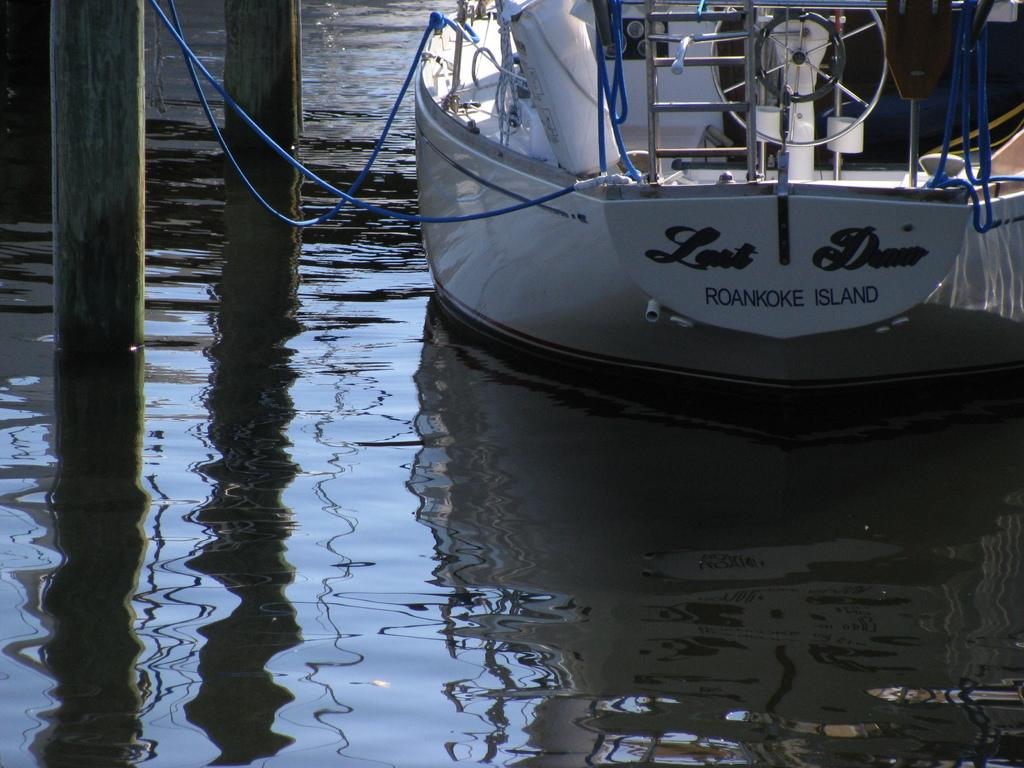What is the main subject of the image? The main subject of the image is a boat. Where is the boat located? The boat is on the water. What can be seen to the left of the boat? There are poles to the left of the boat. What color are the ropes in the image? The ropes in the image are blue. What is another feature visible in the image? There is a ladder in the image. What type of needle is being used to create a rhythm on the boat in the image? There is no needle or rhythm present in the image; it features a boat on the water with poles, ropes, and a ladder. How many fingers can be seen interacting with the ladder in the image? There are no fingers visible in the image; it only shows a boat, poles, ropes, and a ladder. 